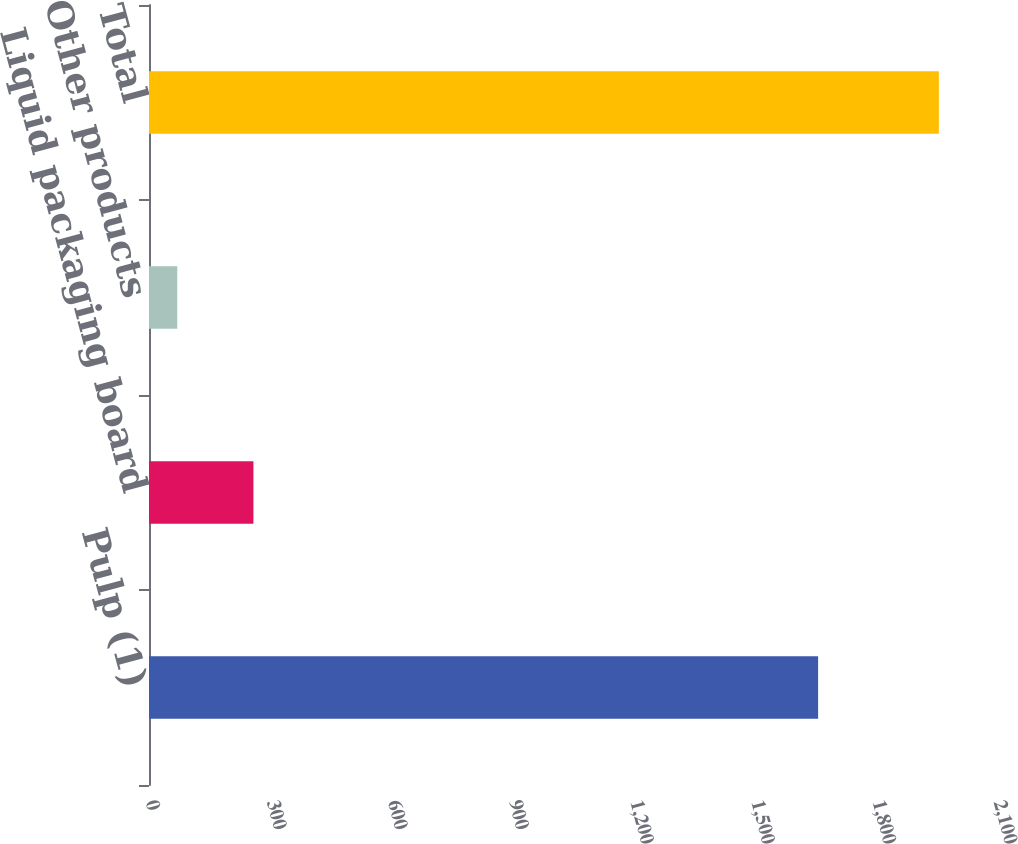Convert chart to OTSL. <chart><loc_0><loc_0><loc_500><loc_500><bar_chart><fcel>Pulp (1)<fcel>Liquid packaging board<fcel>Other products<fcel>Total<nl><fcel>1657<fcel>258.6<fcel>70<fcel>1956<nl></chart> 